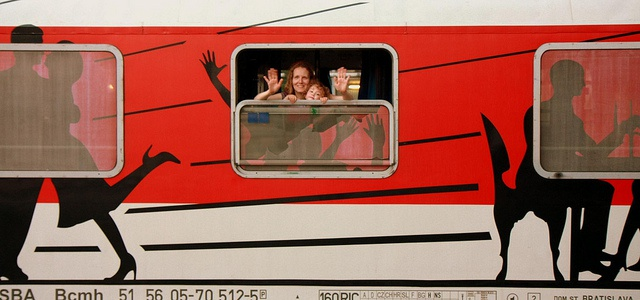Describe the objects in this image and their specific colors. I can see train in red, black, lightgray, and brown tones, people in lightgray, maroon, salmon, and brown tones, and people in lightgray, maroon, salmon, and brown tones in this image. 